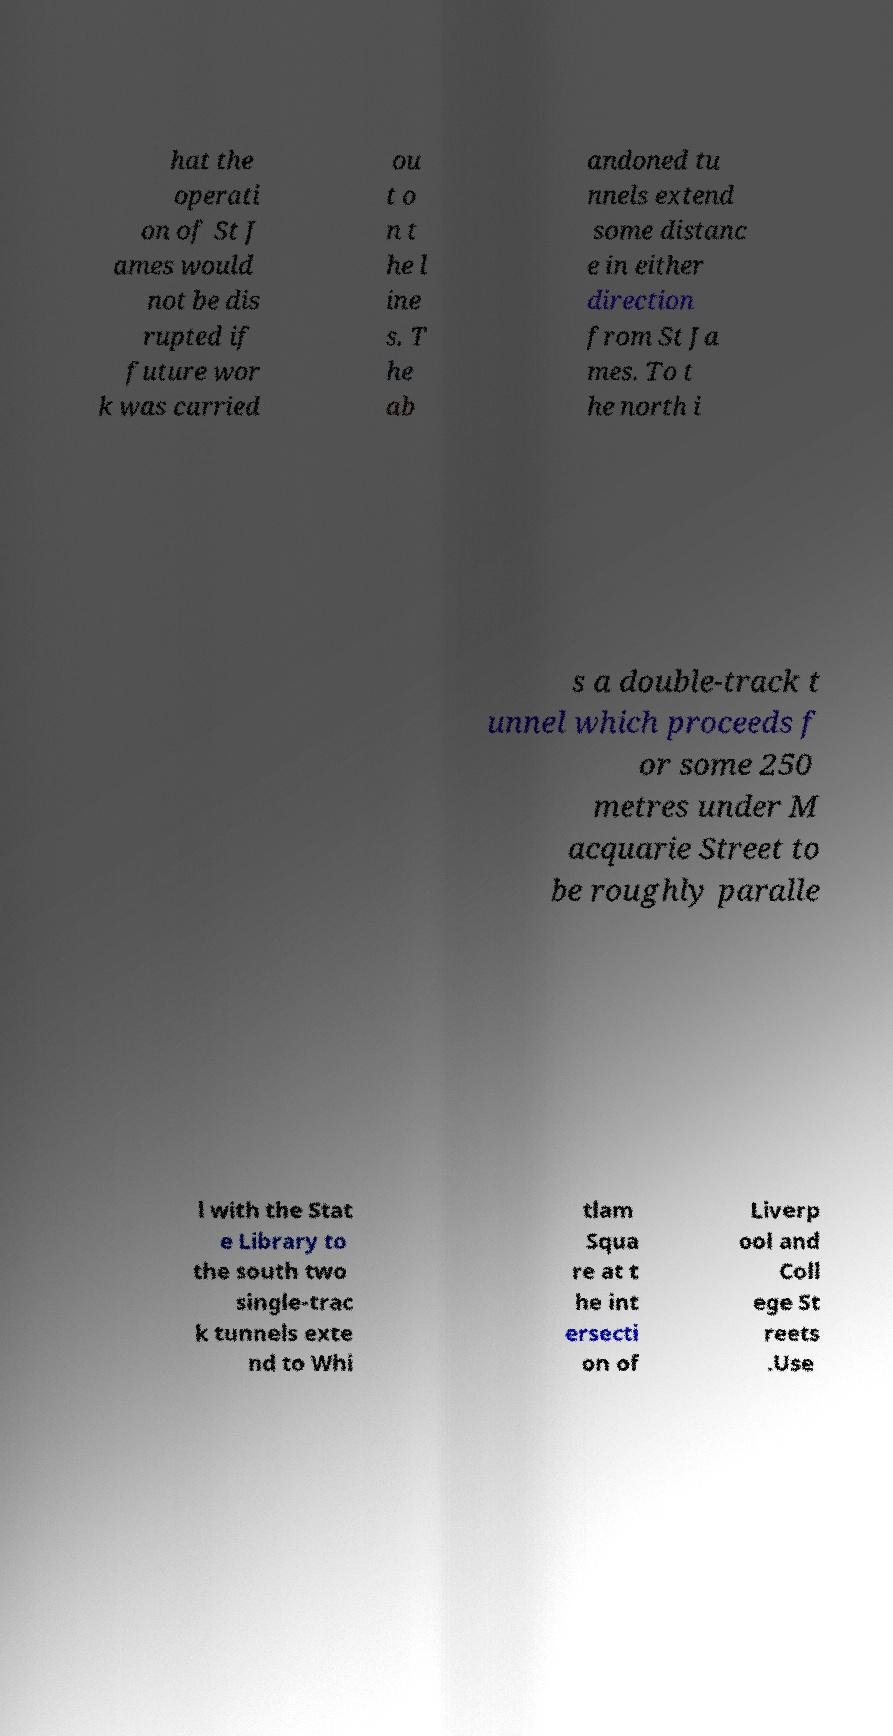For documentation purposes, I need the text within this image transcribed. Could you provide that? hat the operati on of St J ames would not be dis rupted if future wor k was carried ou t o n t he l ine s. T he ab andoned tu nnels extend some distanc e in either direction from St Ja mes. To t he north i s a double-track t unnel which proceeds f or some 250 metres under M acquarie Street to be roughly paralle l with the Stat e Library to the south two single-trac k tunnels exte nd to Whi tlam Squa re at t he int ersecti on of Liverp ool and Coll ege St reets .Use 